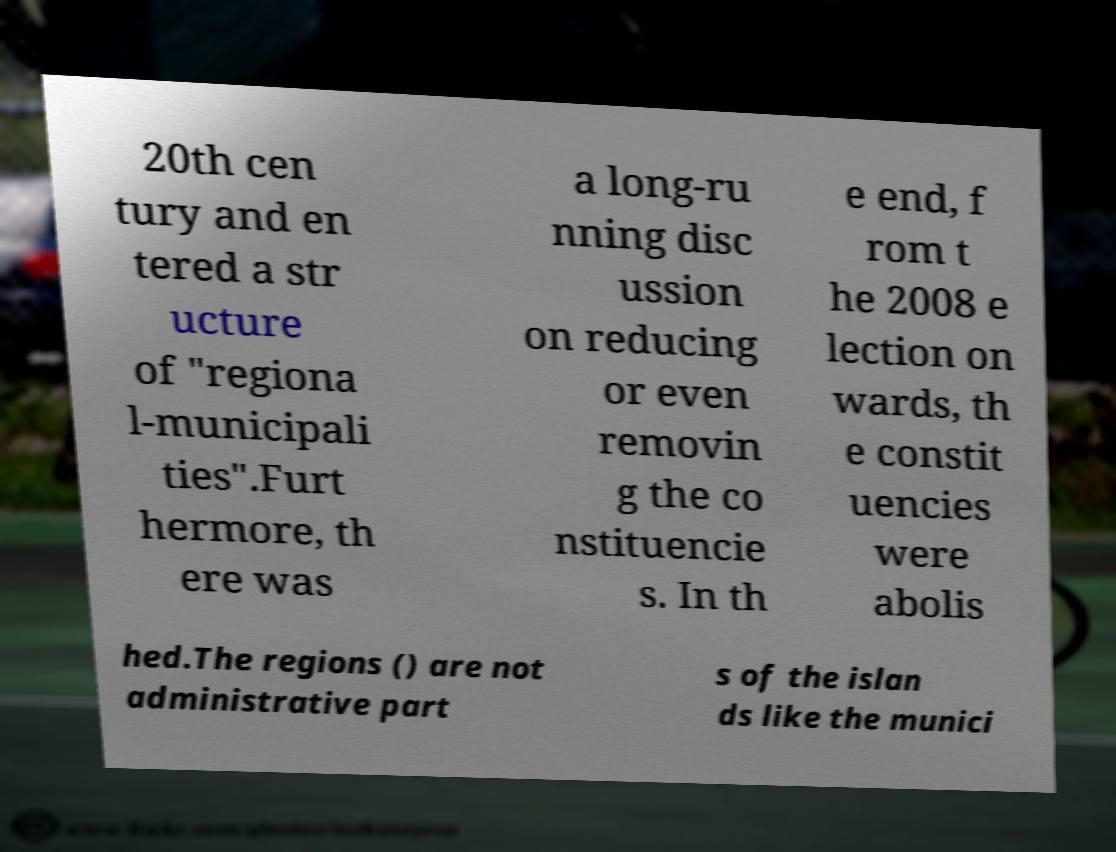What messages or text are displayed in this image? I need them in a readable, typed format. 20th cen tury and en tered a str ucture of "regiona l-municipali ties".Furt hermore, th ere was a long-ru nning disc ussion on reducing or even removin g the co nstituencie s. In th e end, f rom t he 2008 e lection on wards, th e constit uencies were abolis hed.The regions () are not administrative part s of the islan ds like the munici 